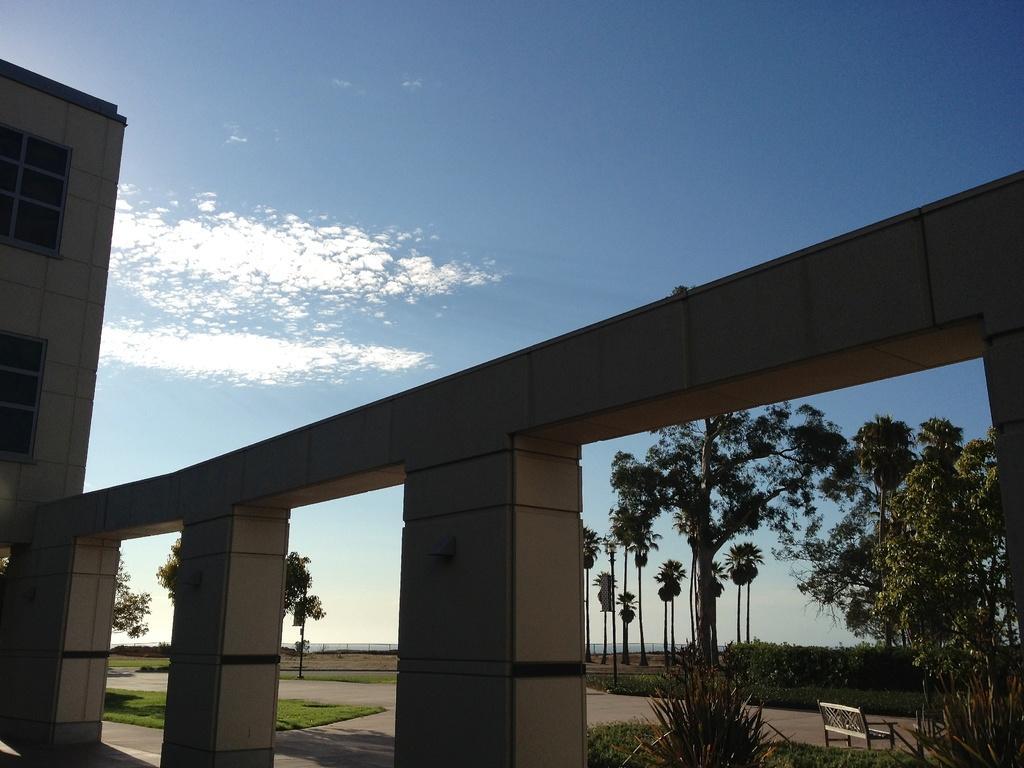Describe this image in one or two sentences. In this image we can see a building with two windows. To the left side of the image we cam sees trees. A bench placed on the ground. In the background, we can see the sky. 